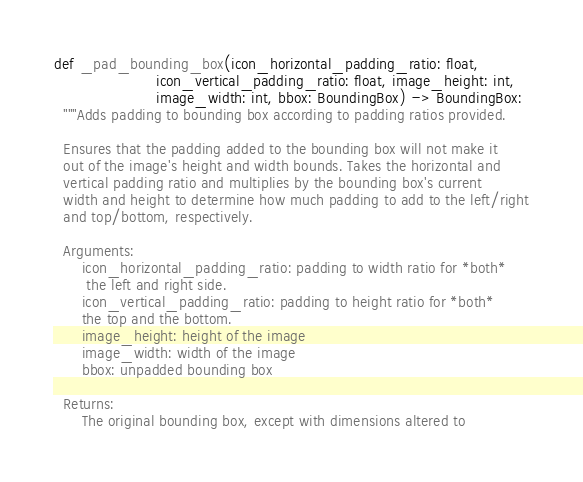<code> <loc_0><loc_0><loc_500><loc_500><_Python_>
def _pad_bounding_box(icon_horizontal_padding_ratio: float,
                      icon_vertical_padding_ratio: float, image_height: int,
                      image_width: int, bbox: BoundingBox) -> BoundingBox:
  """Adds padding to bounding box according to padding ratios provided.

  Ensures that the padding added to the bounding box will not make it
  out of the image's height and width bounds. Takes the horizontal and
  vertical padding ratio and multiplies by the bounding box's current
  width and height to determine how much padding to add to the left/right
  and top/bottom, respectively.

  Arguments:
      icon_horizontal_padding_ratio: padding to width ratio for *both*
       the left and right side.
      icon_vertical_padding_ratio: padding to height ratio for *both*
      the top and the bottom.
      image_height: height of the image
      image_width: width of the image
      bbox: unpadded bounding box

  Returns:
      The original bounding box, except with dimensions altered to</code> 